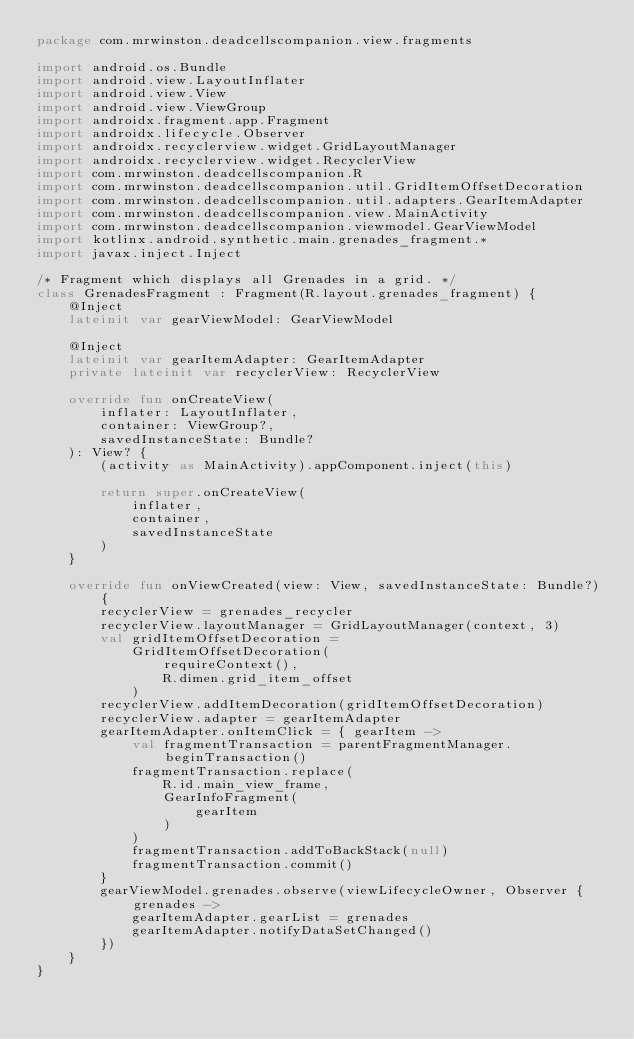<code> <loc_0><loc_0><loc_500><loc_500><_Kotlin_>package com.mrwinston.deadcellscompanion.view.fragments

import android.os.Bundle
import android.view.LayoutInflater
import android.view.View
import android.view.ViewGroup
import androidx.fragment.app.Fragment
import androidx.lifecycle.Observer
import androidx.recyclerview.widget.GridLayoutManager
import androidx.recyclerview.widget.RecyclerView
import com.mrwinston.deadcellscompanion.R
import com.mrwinston.deadcellscompanion.util.GridItemOffsetDecoration
import com.mrwinston.deadcellscompanion.util.adapters.GearItemAdapter
import com.mrwinston.deadcellscompanion.view.MainActivity
import com.mrwinston.deadcellscompanion.viewmodel.GearViewModel
import kotlinx.android.synthetic.main.grenades_fragment.*
import javax.inject.Inject

/* Fragment which displays all Grenades in a grid. */
class GrenadesFragment : Fragment(R.layout.grenades_fragment) {
    @Inject
    lateinit var gearViewModel: GearViewModel

    @Inject
    lateinit var gearItemAdapter: GearItemAdapter
    private lateinit var recyclerView: RecyclerView

    override fun onCreateView(
        inflater: LayoutInflater,
        container: ViewGroup?,
        savedInstanceState: Bundle?
    ): View? {
        (activity as MainActivity).appComponent.inject(this)

        return super.onCreateView(
            inflater,
            container,
            savedInstanceState
        )
    }

    override fun onViewCreated(view: View, savedInstanceState: Bundle?) {
        recyclerView = grenades_recycler
        recyclerView.layoutManager = GridLayoutManager(context, 3)
        val gridItemOffsetDecoration =
            GridItemOffsetDecoration(
                requireContext(),
                R.dimen.grid_item_offset
            )
        recyclerView.addItemDecoration(gridItemOffsetDecoration)
        recyclerView.adapter = gearItemAdapter
        gearItemAdapter.onItemClick = { gearItem ->
            val fragmentTransaction = parentFragmentManager.beginTransaction()
            fragmentTransaction.replace(
                R.id.main_view_frame,
                GearInfoFragment(
                    gearItem
                )
            )
            fragmentTransaction.addToBackStack(null)
            fragmentTransaction.commit()
        }
        gearViewModel.grenades.observe(viewLifecycleOwner, Observer { grenades ->
            gearItemAdapter.gearList = grenades
            gearItemAdapter.notifyDataSetChanged()
        })
    }
}
</code> 